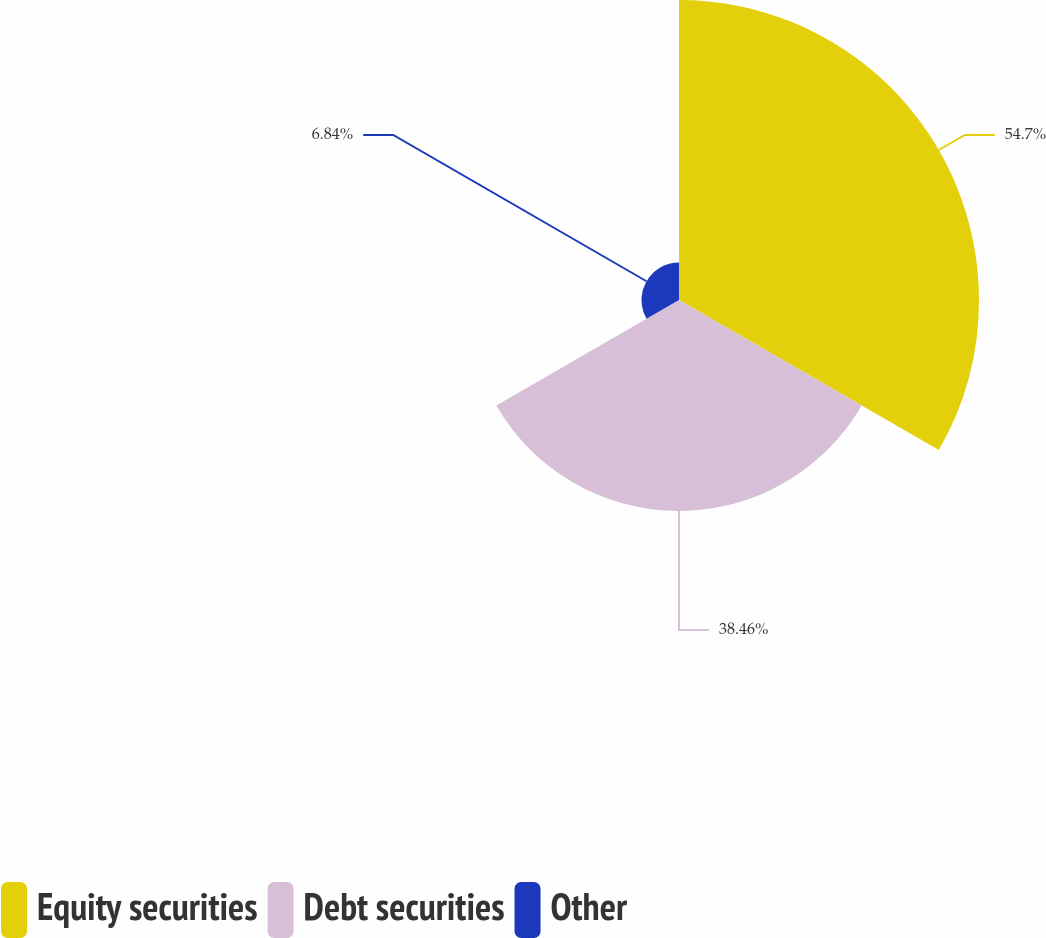<chart> <loc_0><loc_0><loc_500><loc_500><pie_chart><fcel>Equity securities<fcel>Debt securities<fcel>Other<nl><fcel>54.7%<fcel>38.46%<fcel>6.84%<nl></chart> 